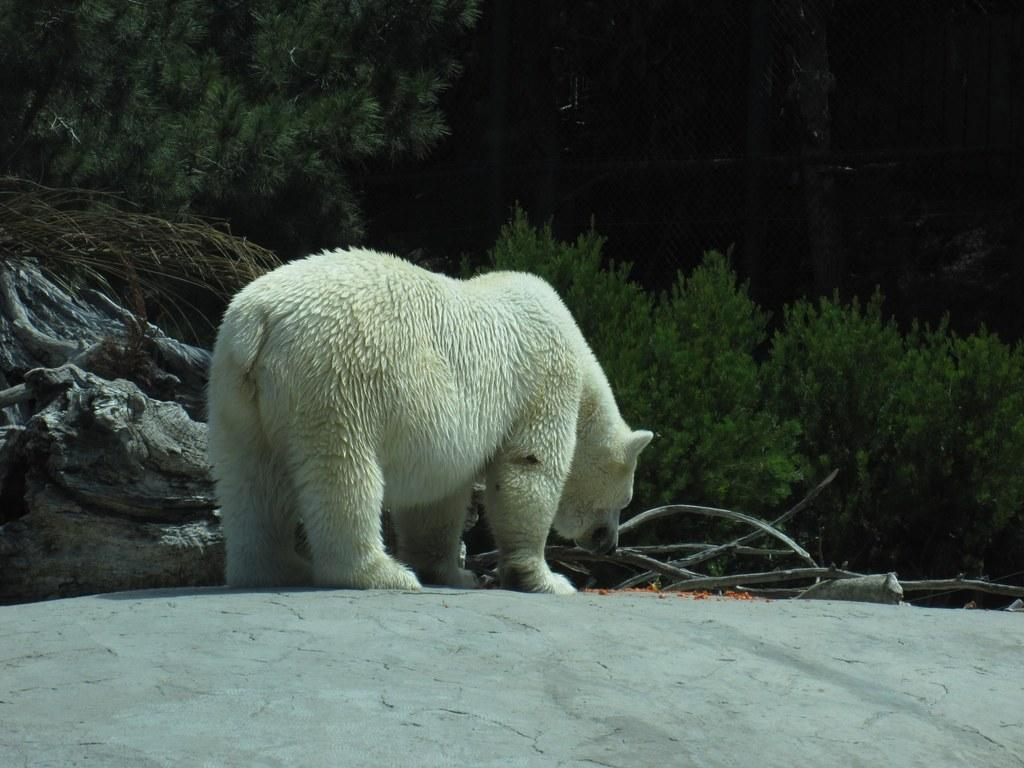What animal is the main subject of the image? There is a polar bear in the image. What is the polar bear doing in the image? The polar bear is standing on the ground. What objects are in front of the polar bear? There are dried stems and rocks in front of the polar bear. What can be seen in the background of the image? There are plants visible in the background of the image. How would you describe the lighting in the image? The top part of the image appears to be dark. What type of iron is the polar bear using to set an example in the image? There is no iron or any indication of setting an example in the image; it simply features a polar bear standing on the ground. 